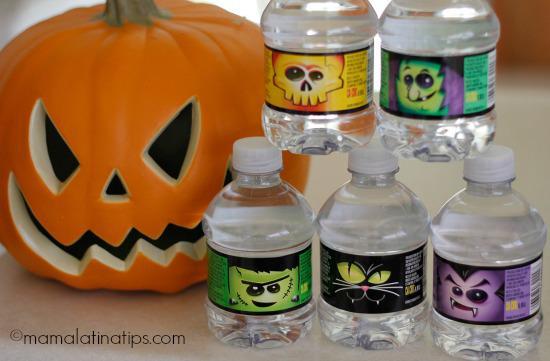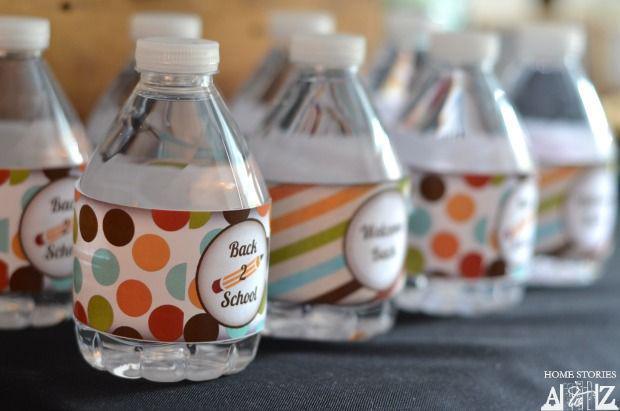The first image is the image on the left, the second image is the image on the right. Given the left and right images, does the statement "There are no more than six water bottles in total." hold true? Answer yes or no. No. The first image is the image on the left, the second image is the image on the right. Examine the images to the left and right. Is the description "In at least one image there are two water bottles with a label that reference a new baby." accurate? Answer yes or no. No. 